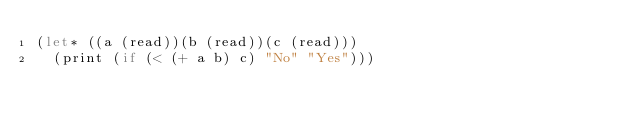<code> <loc_0><loc_0><loc_500><loc_500><_Scheme_>(let* ((a (read))(b (read))(c (read)))
  (print (if (< (+ a b) c) "No" "Yes")))</code> 